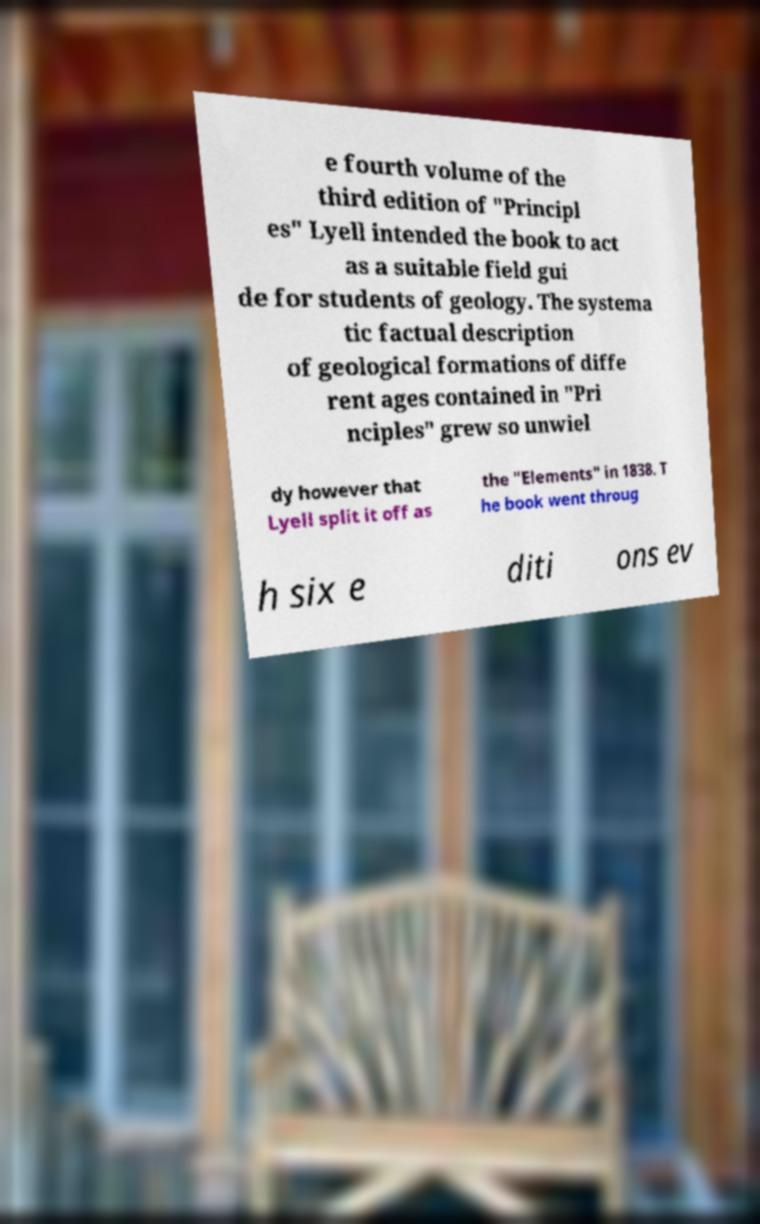Can you read and provide the text displayed in the image?This photo seems to have some interesting text. Can you extract and type it out for me? e fourth volume of the third edition of "Principl es" Lyell intended the book to act as a suitable field gui de for students of geology. The systema tic factual description of geological formations of diffe rent ages contained in "Pri nciples" grew so unwiel dy however that Lyell split it off as the "Elements" in 1838. T he book went throug h six e diti ons ev 